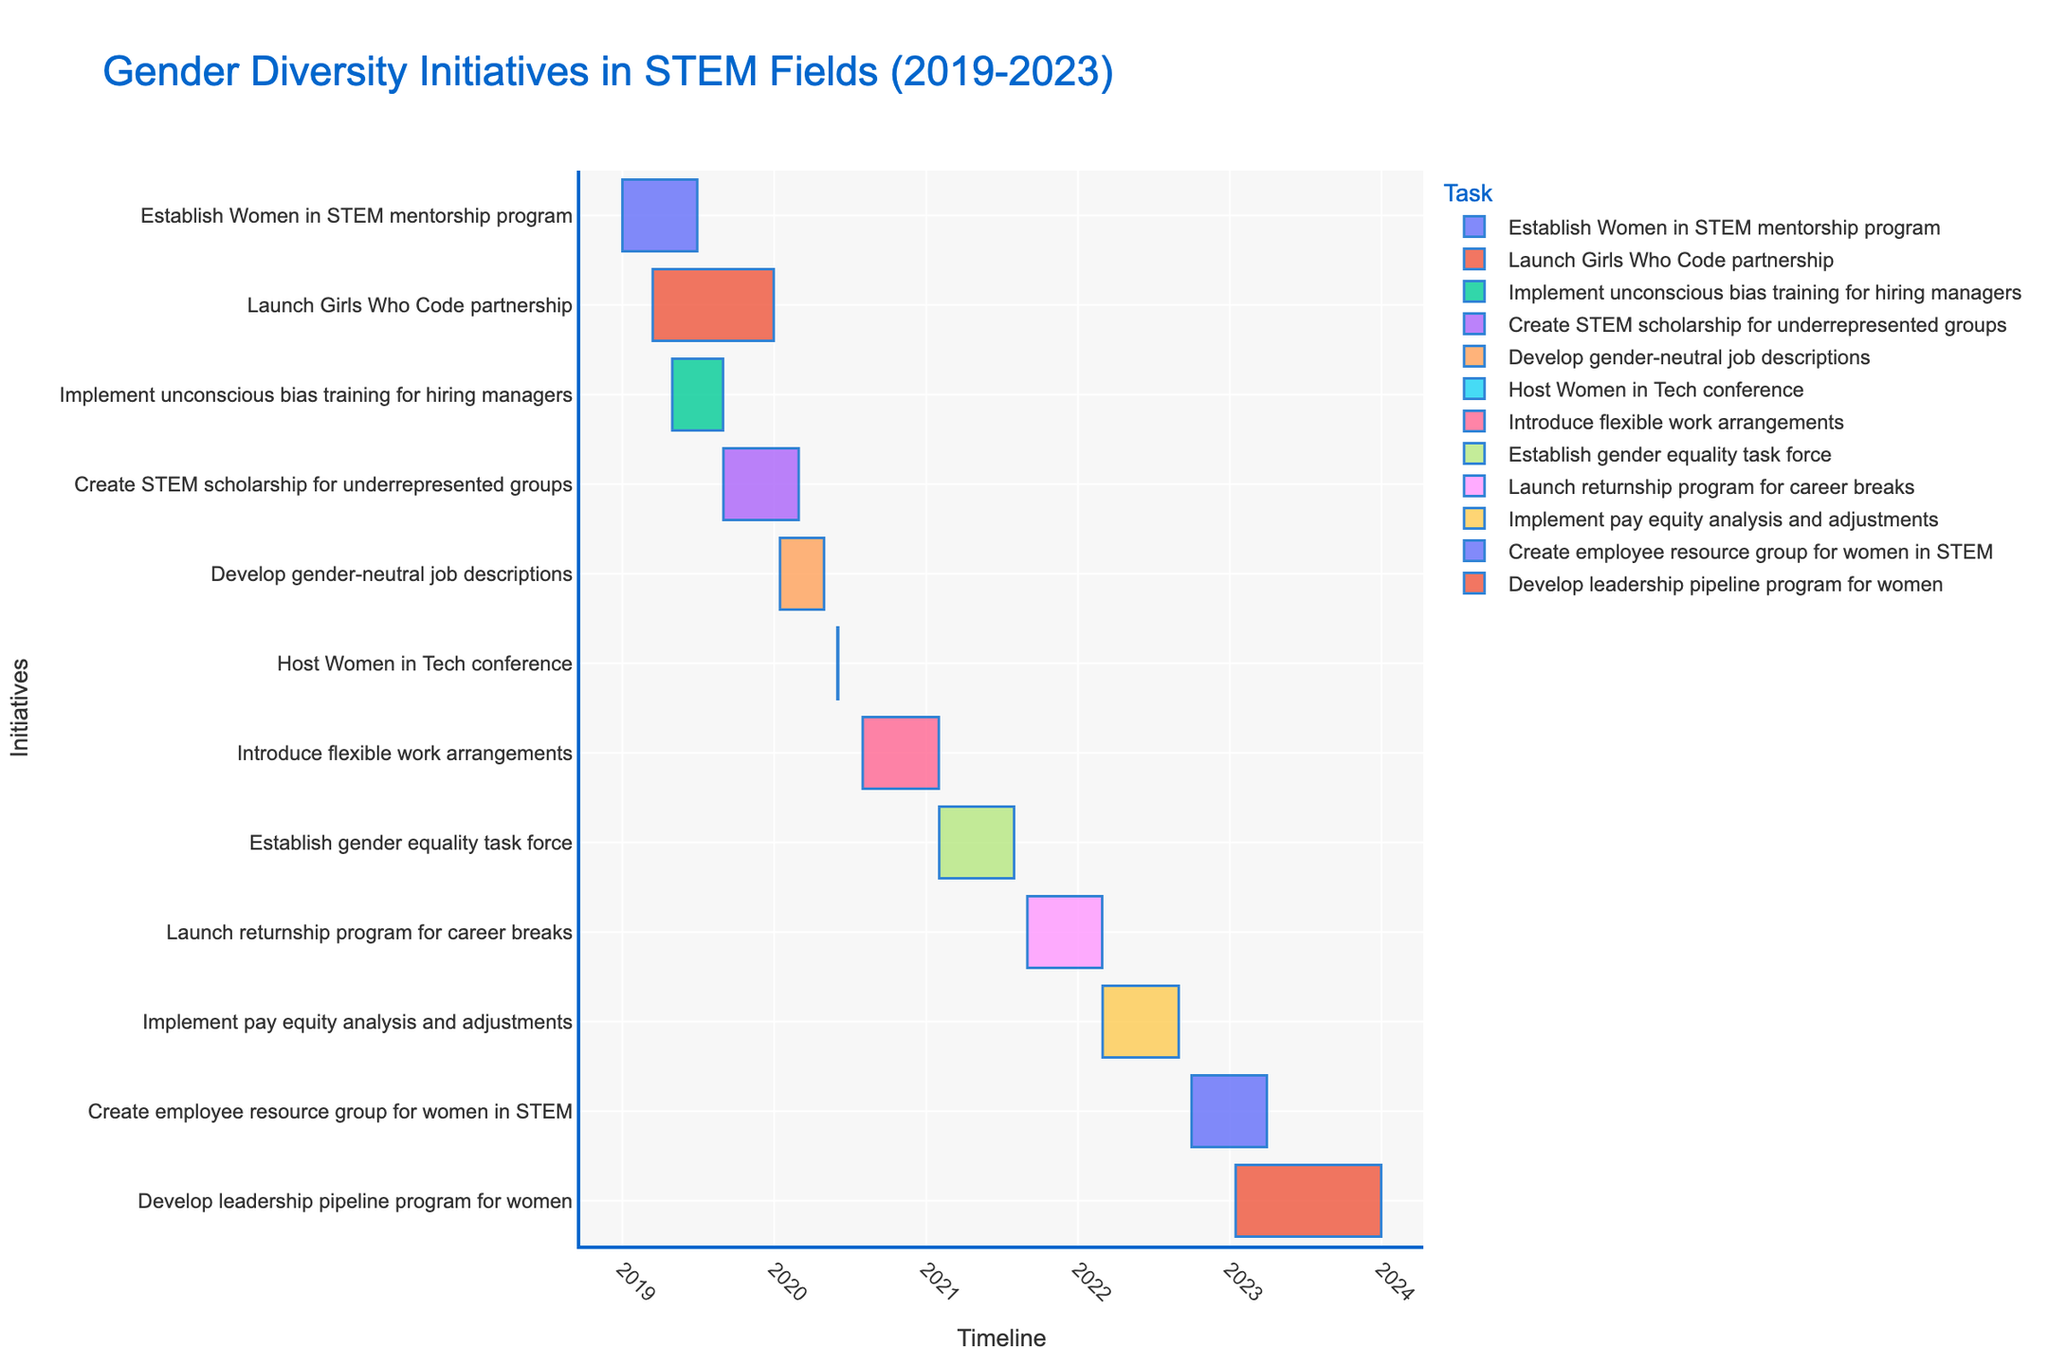How many gender diversity initiatives are displayed in the Gantt chart? Count the number of unique tasks in the figure, which are listed along the y-axis.
Answer: 12 When did the 'Establish Women in STEM mentorship program' initiative start and end? Look at the 'Establish Women in STEM mentorship program' bar on the Gantt chart. The start date is at the left end of the bar, and the end date is at the right end.
Answer: Start: January 1, 2019, End: June 30, 2019 Which initiative took place entirely within 2020? Identify tasks that have both their start and end dates within the year 2020.
Answer: Host Women in Tech conference Which initiatives lasted for less than six months? Calculate the duration for each task by comparing the start and end dates, and identify tasks with durations less than six months.
Answer: Establish Women in STEM mentorship program, Implement unconscious bias training for hiring managers, Develop gender-neutral job descriptions, Host Women in Tech conference How does the duration of 'Create employee resource group for women in STEM' compare to 'Implement pay equity analysis and adjustments'? Check the duration of each task by subtracting the start date from the end date. Compare the two durations to see which one is longer.
Answer: 'Create employee resource group for women in STEM' is slightly shorter Which initiatives overlapped in the second half of 2021? Review the Gantt chart to see which bars (initiatives) span the second half of 2021 (July-December). Check for overlapping bars in that period.
Answer: Establish gender equality task force, Launch returnship program for career breaks What is the title of the Gantt chart? Locate the title text typically positioned at the top of the chart.
Answer: Gender Diversity Initiatives in STEM Fields (2019-2023) Which initiative started first in 2023? Identify the bars that start in 2023 and determine which one begins the earliest by comparing their start dates.
Answer: Develop leadership pipeline program for women What is the average duration of initiatives starting in 2019? Sum the durations of all initiatives that started in 2019 and divide by the number of these initiatives. The duration for each task is calculated by subtracting the start date from the end date. Steps to follow:
1. Establish Women in STEM mentorship program: 6 months
2. Launch Girls Who Code partnership: 9.5 months
3. Implement unconscious bias training for hiring managers: 4 months
4. Create STEM scholarship for underrepresented groups: 6 months
Average: (6 + 9.5 + 4 + 6) / 4 = 6.375
Answer: 6.375 months 